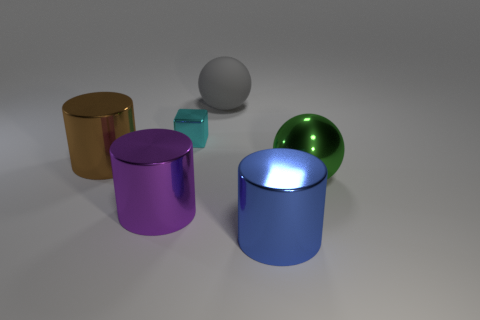Add 2 matte balls. How many objects exist? 8 Subtract all cubes. How many objects are left? 5 Add 4 purple shiny cylinders. How many purple shiny cylinders are left? 5 Add 2 green spheres. How many green spheres exist? 3 Subtract 0 brown blocks. How many objects are left? 6 Subtract all yellow shiny objects. Subtract all cyan shiny objects. How many objects are left? 5 